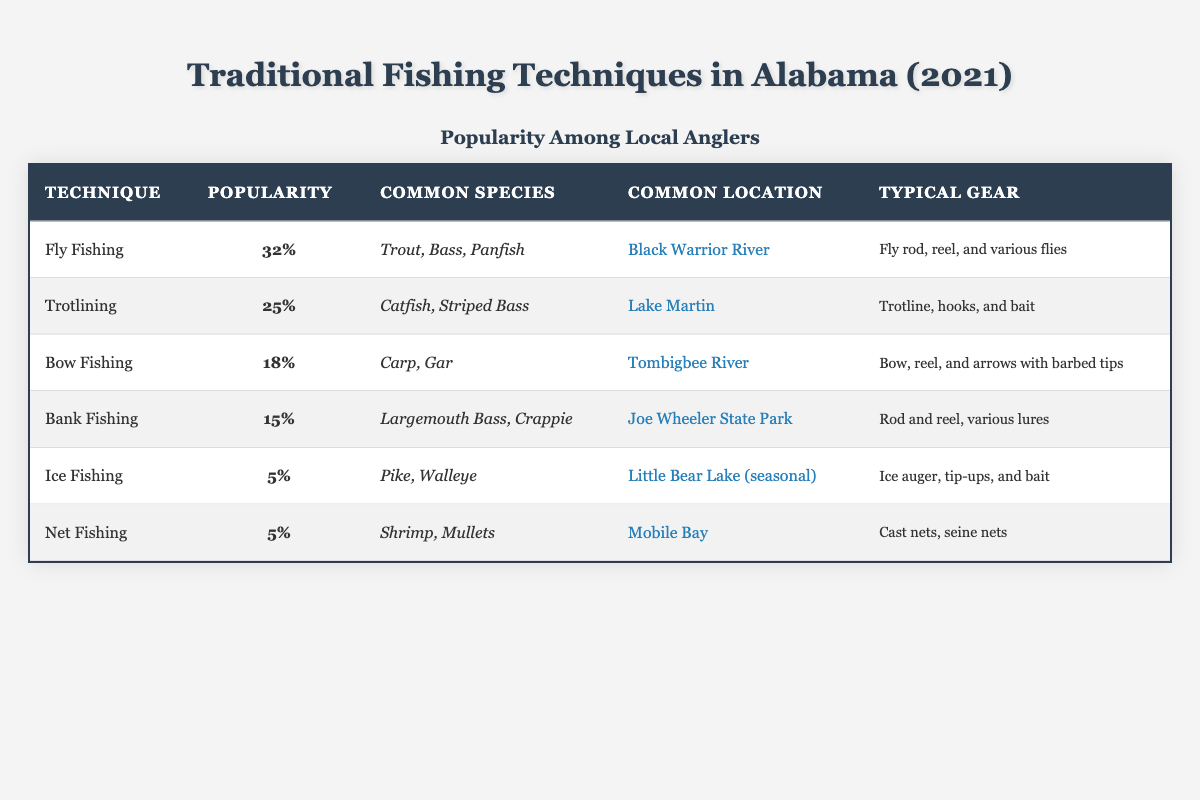What is the most popular fishing technique among local anglers? The table shows that Fly Fishing has the highest popularity percentage at 32%.
Answer: Fly Fishing Which technique targets the species "Shrimp"? The data indicates that Net Fishing targets Shrimp, as shown in the common species column.
Answer: Net Fishing How many techniques have a popularity percentage of 5%? Two techniques, Ice Fishing and Net Fishing, both have a popularity percentage of 5%, so we count them.
Answer: 2 What is the total popularity percentage of the two least popular techniques? The two least popular techniques, Ice Fishing and Net Fishing, each have a popularity percentage of 5%. Therefore, the total is 5 + 5 = 10.
Answer: 10 Is it true that Bank Fishing is more popular than Bow Fishing? Yes, Bank Fishing has a popularity percentage of 15%, which is higher than Bow Fishing's popularity of 18%.
Answer: Yes Which species is most commonly targeted with Fly Fishing? The table lists Trout, Bass, and Panfish as common species targeted with Fly Fishing.
Answer: Trout, Bass, Panfish What fishing technique has the lowest popularity and what is it? Ice Fishing and Net Fishing both have a popularity of 5%, which are the lowest from the data.
Answer: Ice Fishing and Net Fishing How does the popularity of Trotlining compare to Fly Fishing? Trotlining has a popularity percentage of 25%, which is lower than Fly Fishing's 32%.
Answer: Lower Which fishing technique uses a bow and arrows? The table identifies Bow Fishing as the technique that uses a bow and arrows with barbed tips.
Answer: Bow Fishing What common location is associated with Bank Fishing? According to the table, Joe Wheeler State Park is the common location for Bank Fishing.
Answer: Joe Wheeler State Park 